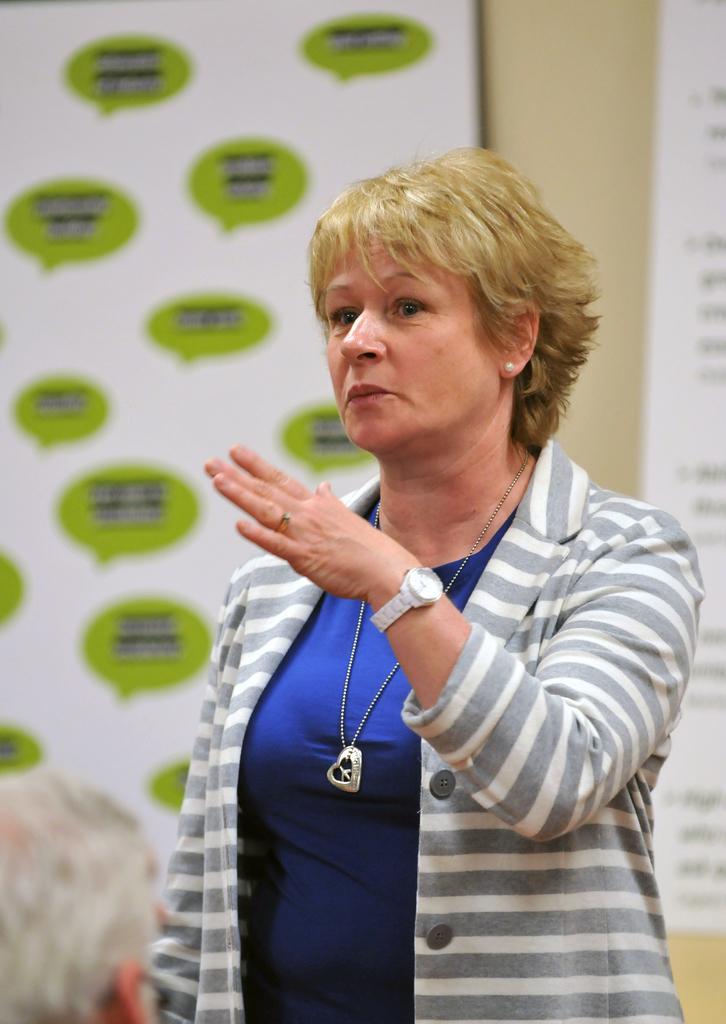Can you describe this image briefly? In the image there is a blond haired woman in white and grey sweat shirt standing in the middle and behind her there are banners on the wall. 